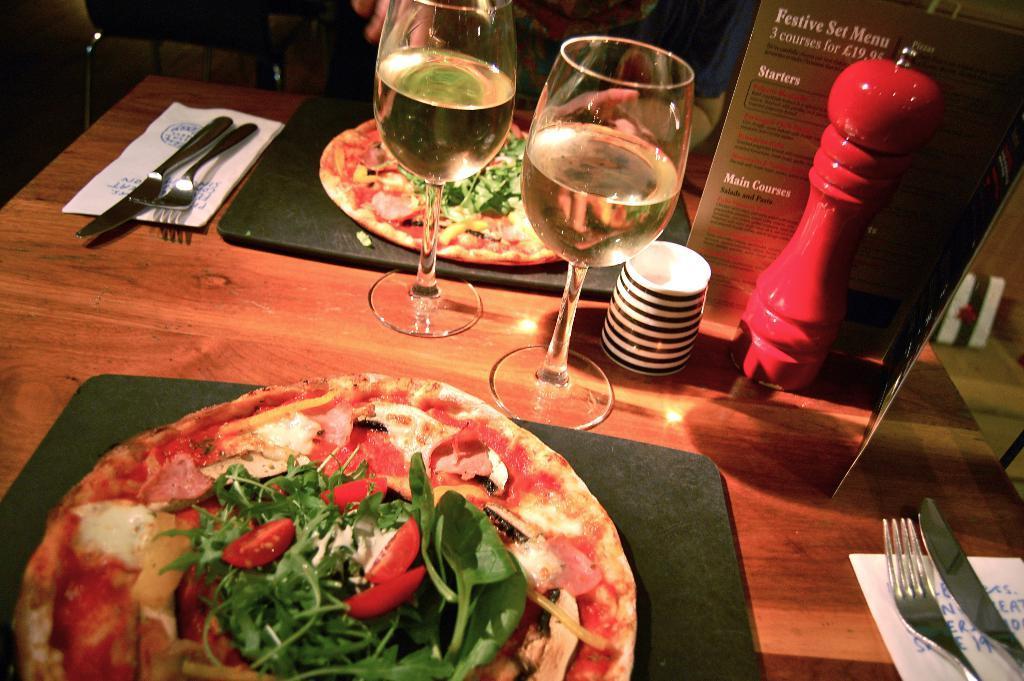Could you give a brief overview of what you see in this image? This is a wooden table where two pizza, two glasses and spoons are kept on it. 